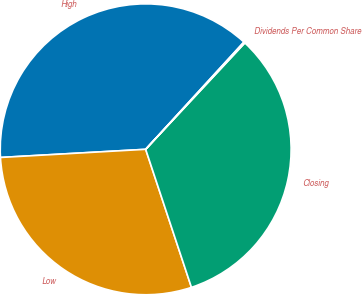Convert chart. <chart><loc_0><loc_0><loc_500><loc_500><pie_chart><fcel>High<fcel>Low<fcel>Closing<fcel>Dividends Per Common Share<nl><fcel>37.69%<fcel>29.2%<fcel>32.96%<fcel>0.14%<nl></chart> 